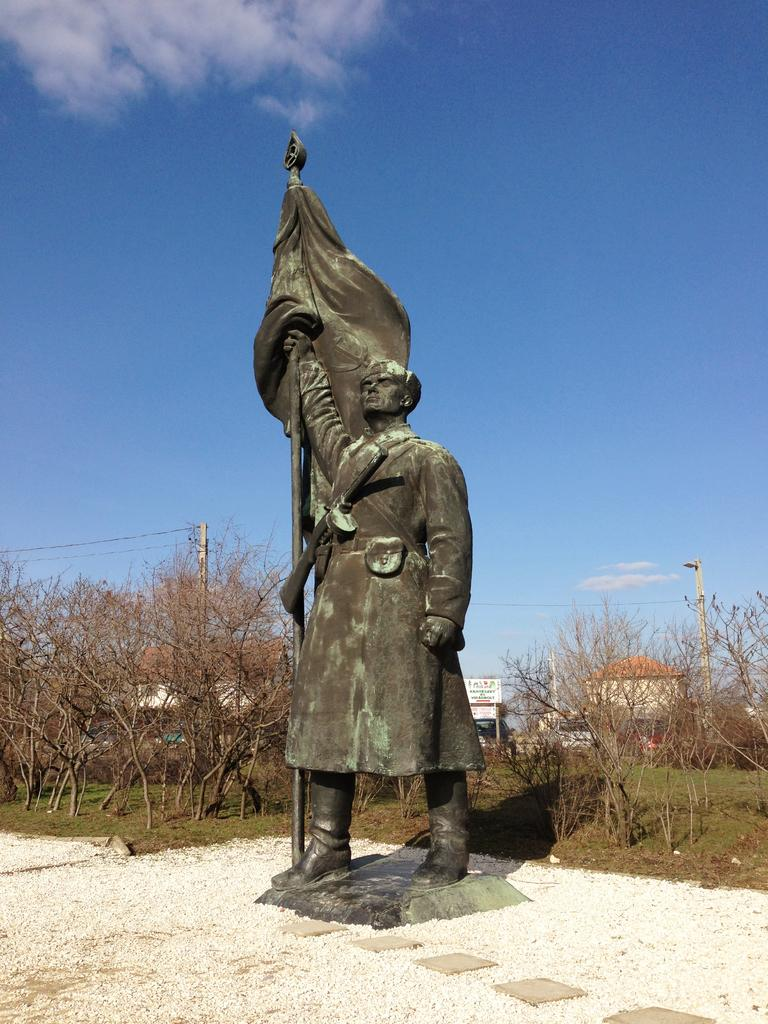What is the main subject of the image? There is a statue of a person in the image. How is the statue positioned in the image? The statue is placed on the ground. What can be seen in the background of the image? There are buildings, trees, poles, and the sky visible in the background of the image. What type of flowers are growing around the statue in the image? There are no flowers visible around the statue in the image. How much sugar is present in the oatmeal bowl next to the statue? There is no oatmeal or bowl present in the image, so it is impossible to determine the amount of sugar. 